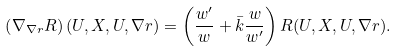<formula> <loc_0><loc_0><loc_500><loc_500>\left ( \nabla _ { \nabla r } R \right ) ( U , X , U , \nabla r ) = \left ( \frac { w ^ { \prime } } { w } + \bar { k } \frac { w } { w ^ { \prime } } \right ) R ( U , X , U , \nabla r ) .</formula> 